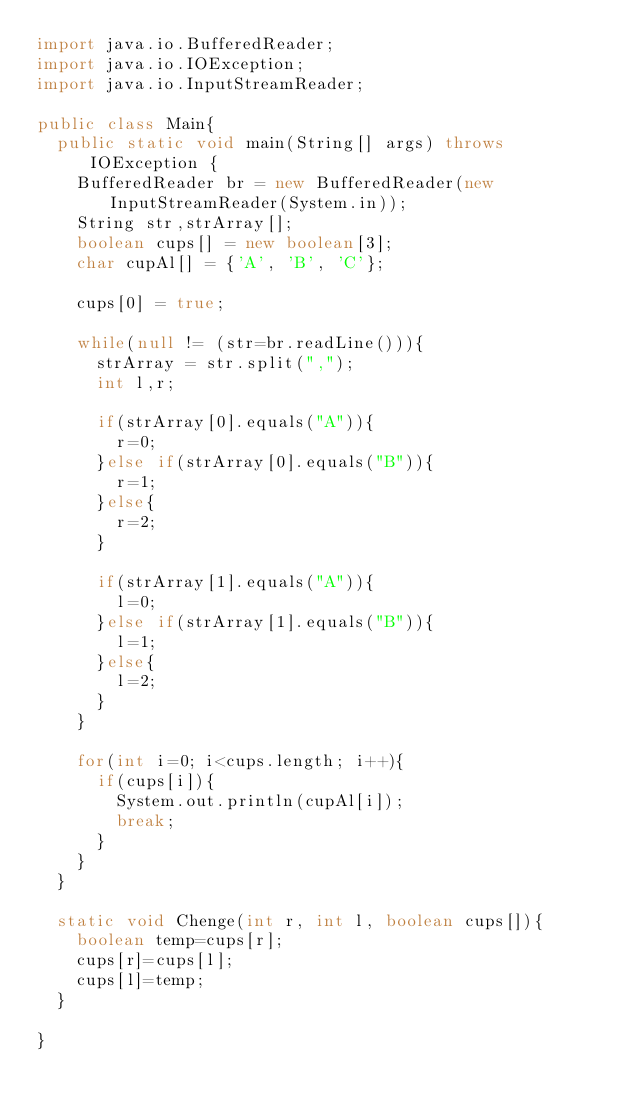Convert code to text. <code><loc_0><loc_0><loc_500><loc_500><_Java_>import java.io.BufferedReader;
import java.io.IOException;
import java.io.InputStreamReader;

public class Main{
	public static void main(String[] args) throws IOException {
		BufferedReader br = new BufferedReader(new InputStreamReader(System.in));
		String str,strArray[];
		boolean cups[] = new boolean[3];
		char cupAl[] = {'A', 'B', 'C'};

		cups[0] = true;

		while(null != (str=br.readLine())){
			strArray = str.split(",");
			int l,r;

			if(strArray[0].equals("A")){
				r=0;
			}else if(strArray[0].equals("B")){
				r=1;
			}else{
				r=2;
			}

			if(strArray[1].equals("A")){
				l=0;
			}else if(strArray[1].equals("B")){
				l=1;
			}else{
				l=2;
			}
		}

		for(int i=0; i<cups.length; i++){
			if(cups[i]){
				System.out.println(cupAl[i]);
				break;
			}
		}
	}

	static void Chenge(int r, int l, boolean cups[]){
		boolean temp=cups[r];
		cups[r]=cups[l];
		cups[l]=temp;
	}

}</code> 